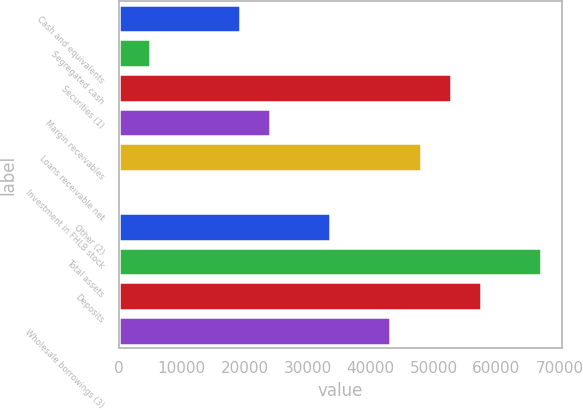Convert chart. <chart><loc_0><loc_0><loc_500><loc_500><bar_chart><fcel>Cash and equivalents<fcel>Segregated cash<fcel>Securities (1)<fcel>Margin receivables<fcel>Loans receivable net<fcel>Investment in FHLB stock<fcel>Other (2)<fcel>Total assets<fcel>Deposits<fcel>Wholesale borrowings (3)<nl><fcel>19260.3<fcel>4920.23<fcel>52720.5<fcel>24040.3<fcel>47940.5<fcel>140.2<fcel>33600.4<fcel>67060.6<fcel>57500.6<fcel>43160.5<nl></chart> 